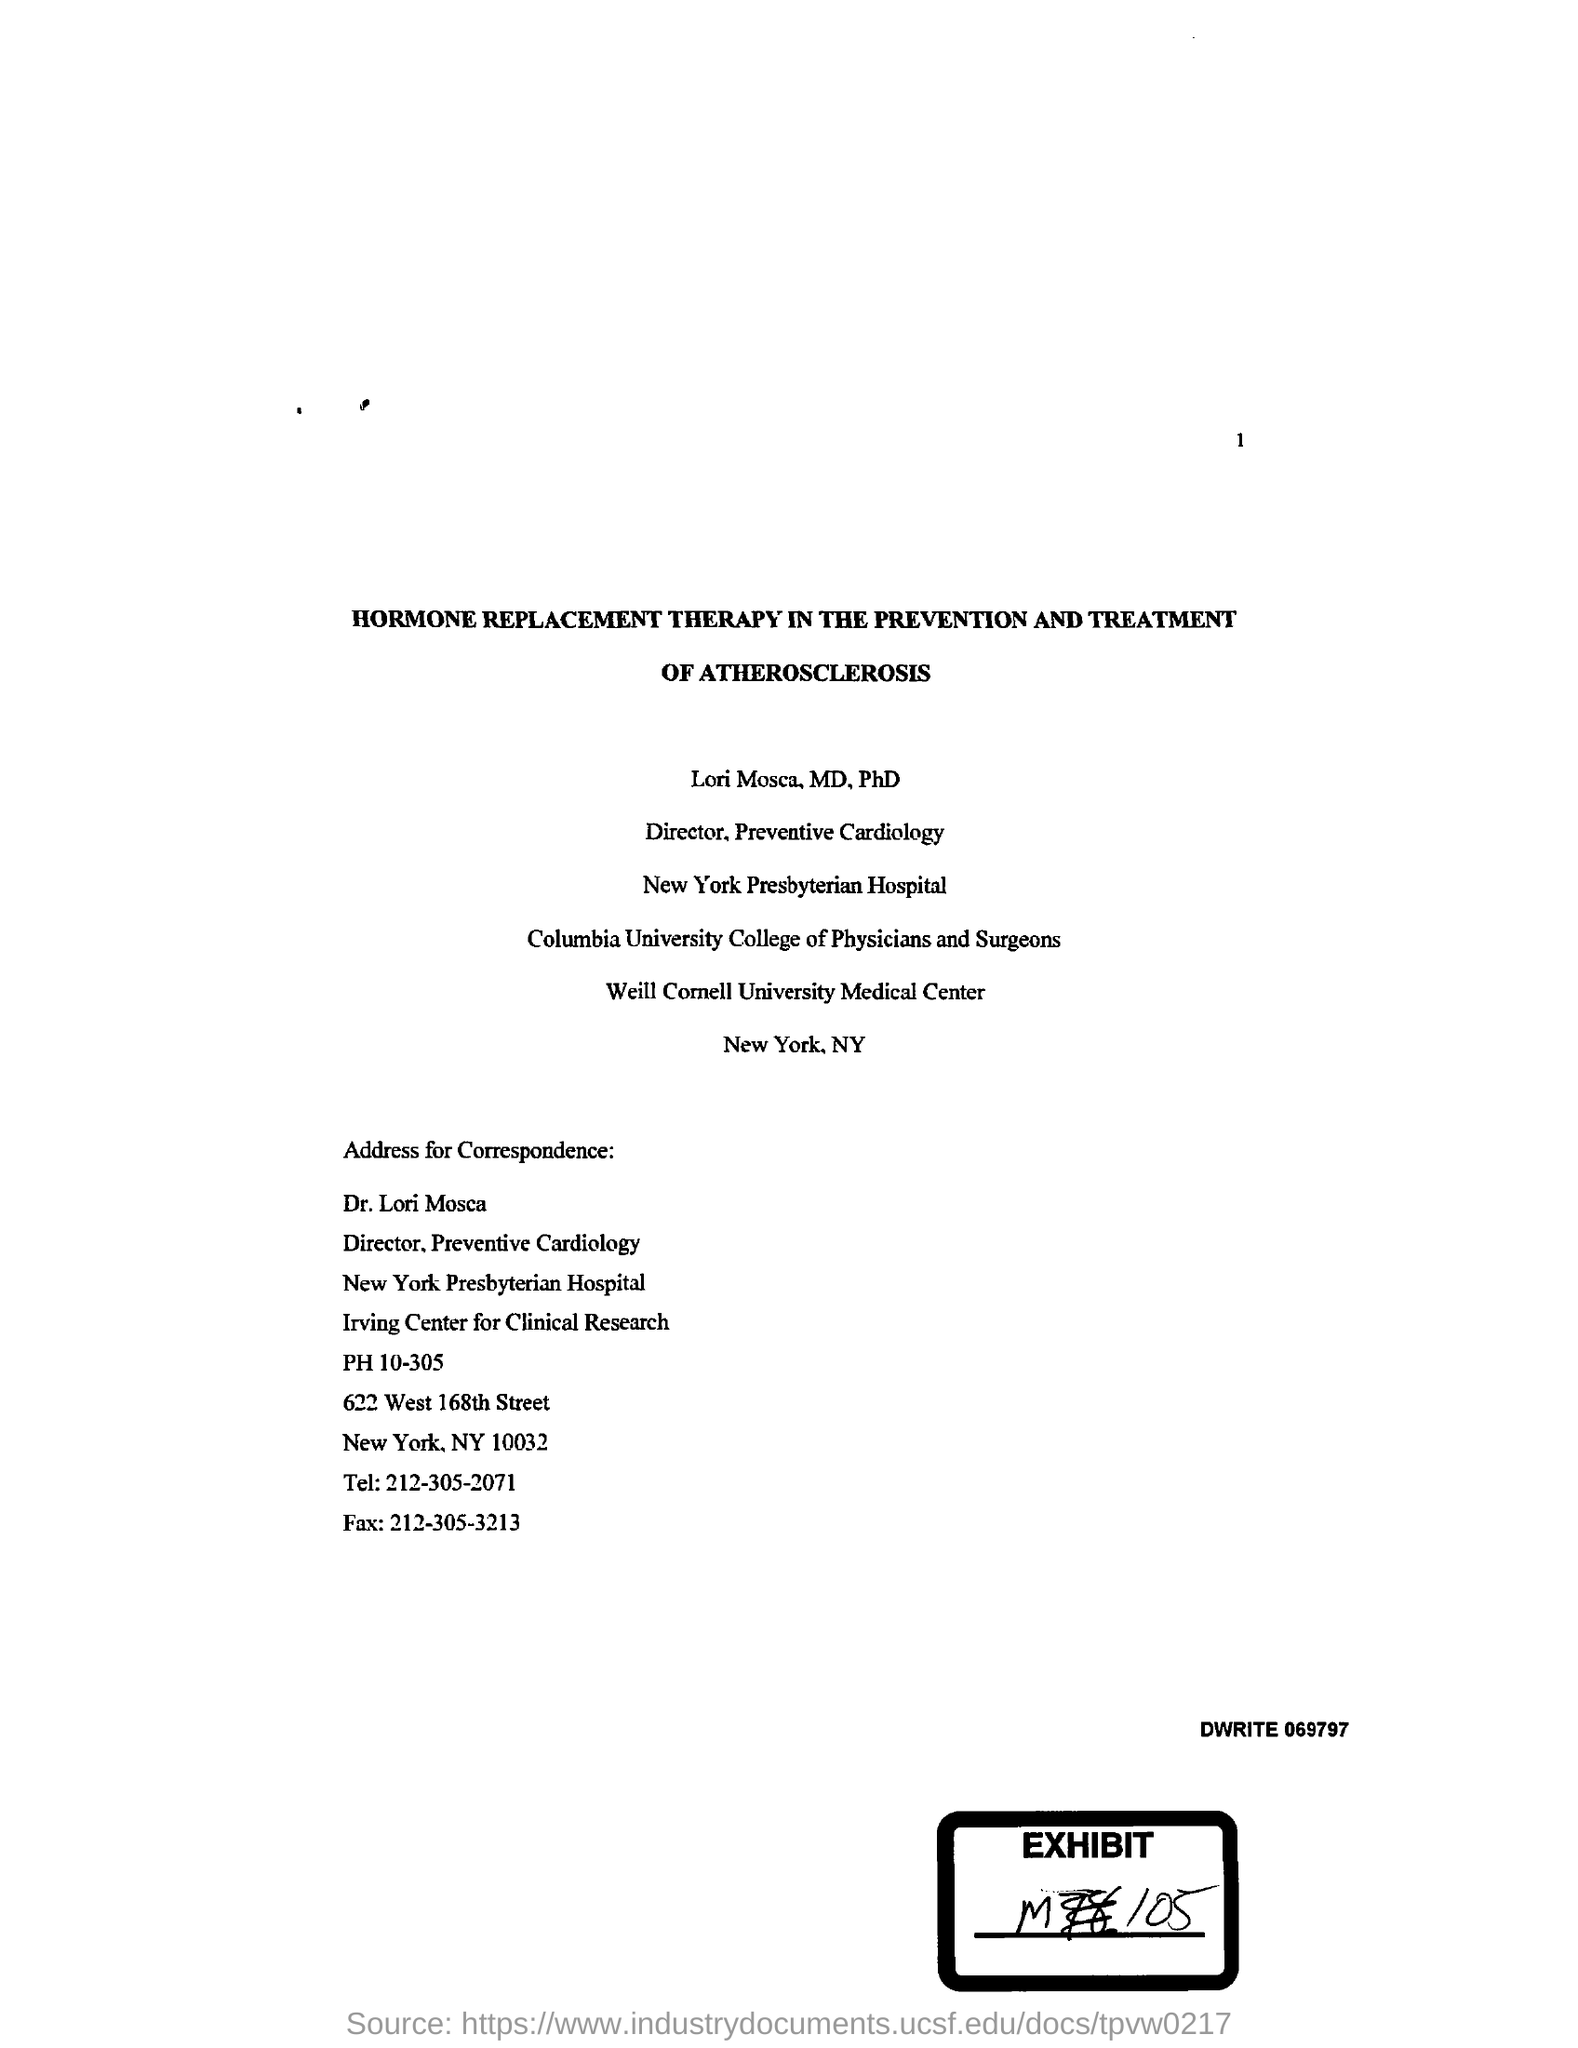In which hospital does dr.lori mosca work ?
Make the answer very short. New York Presbyterian Hospital. What is the fax no mentioned in the given page ?
Offer a terse response. 212-305-3213. What is the tel no given in the letter ?
Your answer should be compact. 212-305-2071. What is the name of the therapy mentioned in the given page ?
Make the answer very short. Hormone replacement therapy. 